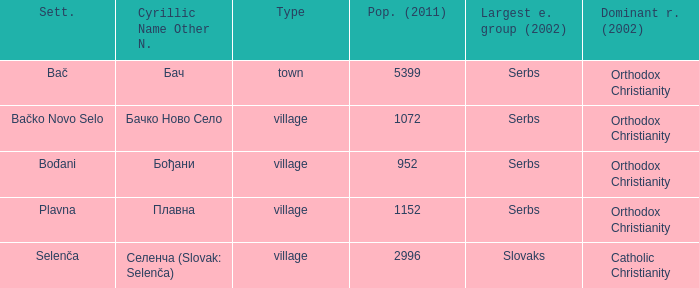How to you write  плавна with the latin alphabet? Plavna. 